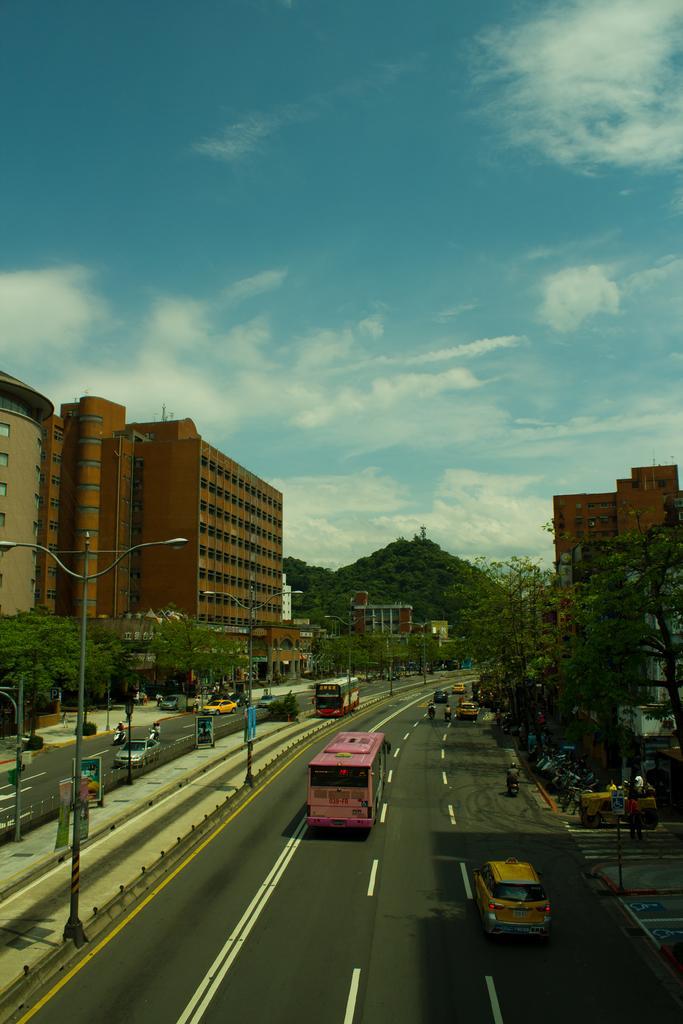Please provide a concise description of this image. In this image, there are a few vehicles, buildings, people, poles, trees, hills and boards. We can see the ground with some objects. We can also see the sky with clouds. 